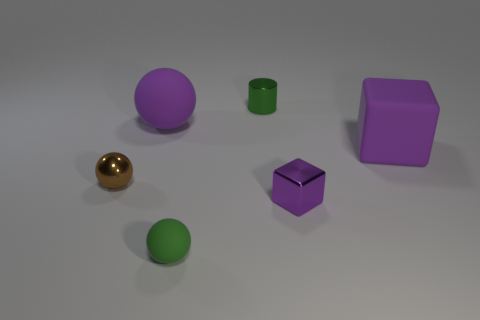Add 2 purple shiny things. How many objects exist? 8 Subtract all large purple balls. How many balls are left? 2 Subtract 1 balls. How many balls are left? 2 Subtract all blocks. How many objects are left? 4 Subtract all tiny things. Subtract all rubber cubes. How many objects are left? 1 Add 5 small brown objects. How many small brown objects are left? 6 Add 1 big blue blocks. How many big blue blocks exist? 1 Subtract 0 brown cylinders. How many objects are left? 6 